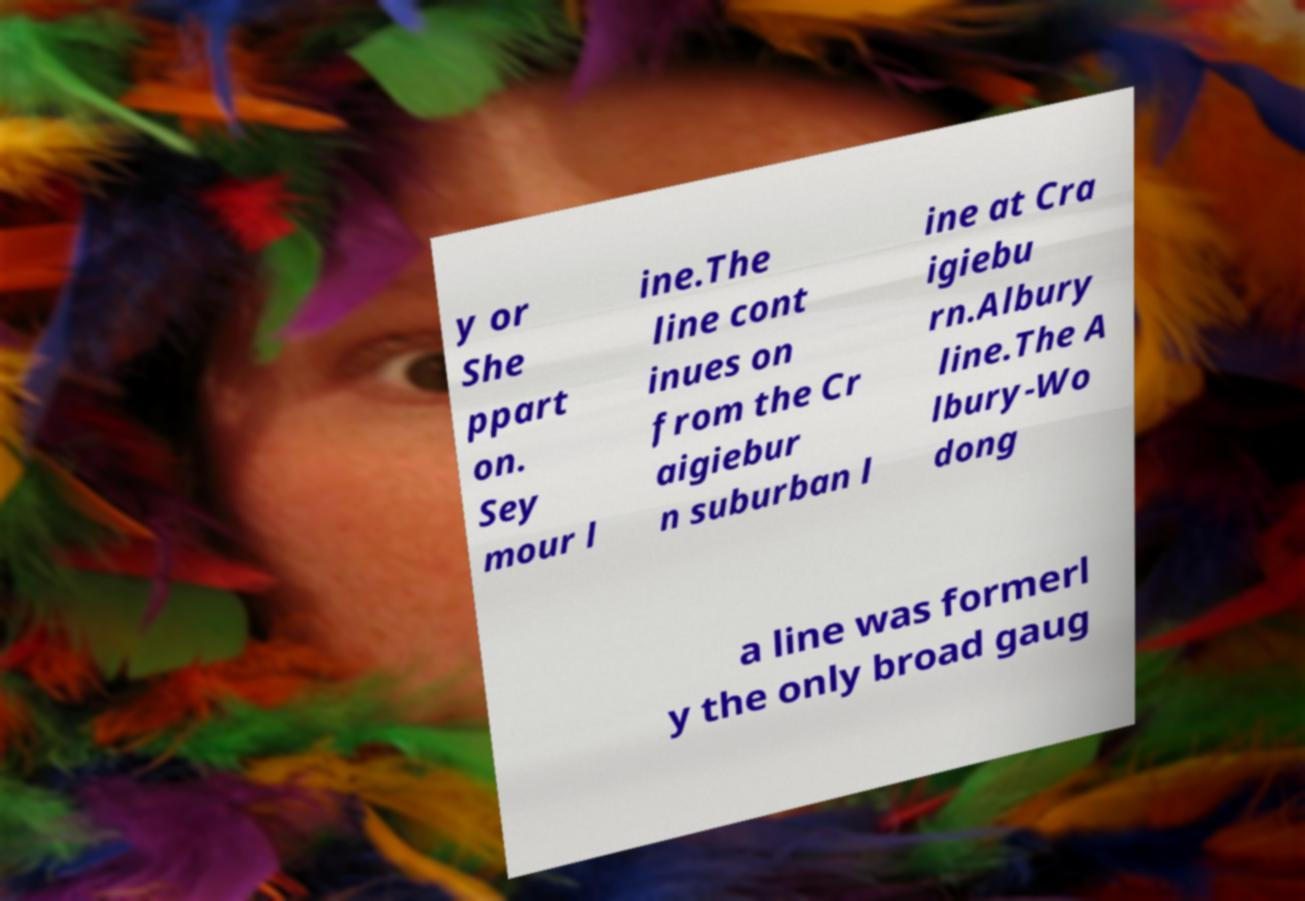I need the written content from this picture converted into text. Can you do that? y or She ppart on. Sey mour l ine.The line cont inues on from the Cr aigiebur n suburban l ine at Cra igiebu rn.Albury line.The A lbury-Wo dong a line was formerl y the only broad gaug 